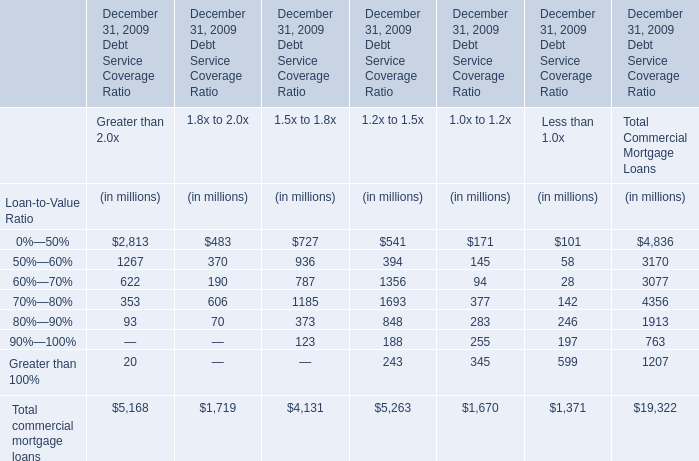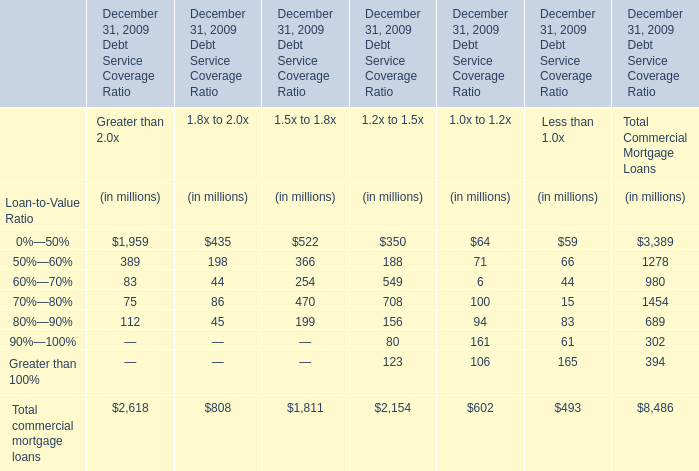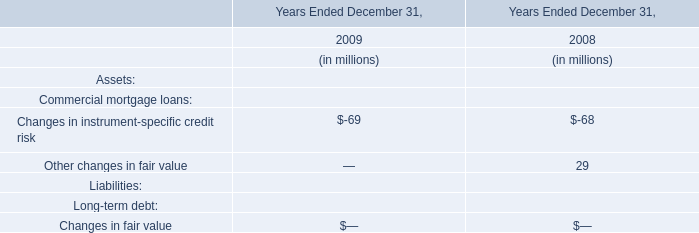As As the chart 1 shows,what's the value of all Loan-to-Value Ratio for Debt Service Coverage Ratio 1.2x to 1.5x at December 31, 2009 greater than 500 million? (in million) 
Computations: (549 + 708)
Answer: 1257.0. 